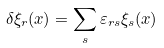Convert formula to latex. <formula><loc_0><loc_0><loc_500><loc_500>\delta \xi _ { r } ( { x } ) = \sum _ { s } \varepsilon _ { r s } \xi _ { s } ( { x } )</formula> 